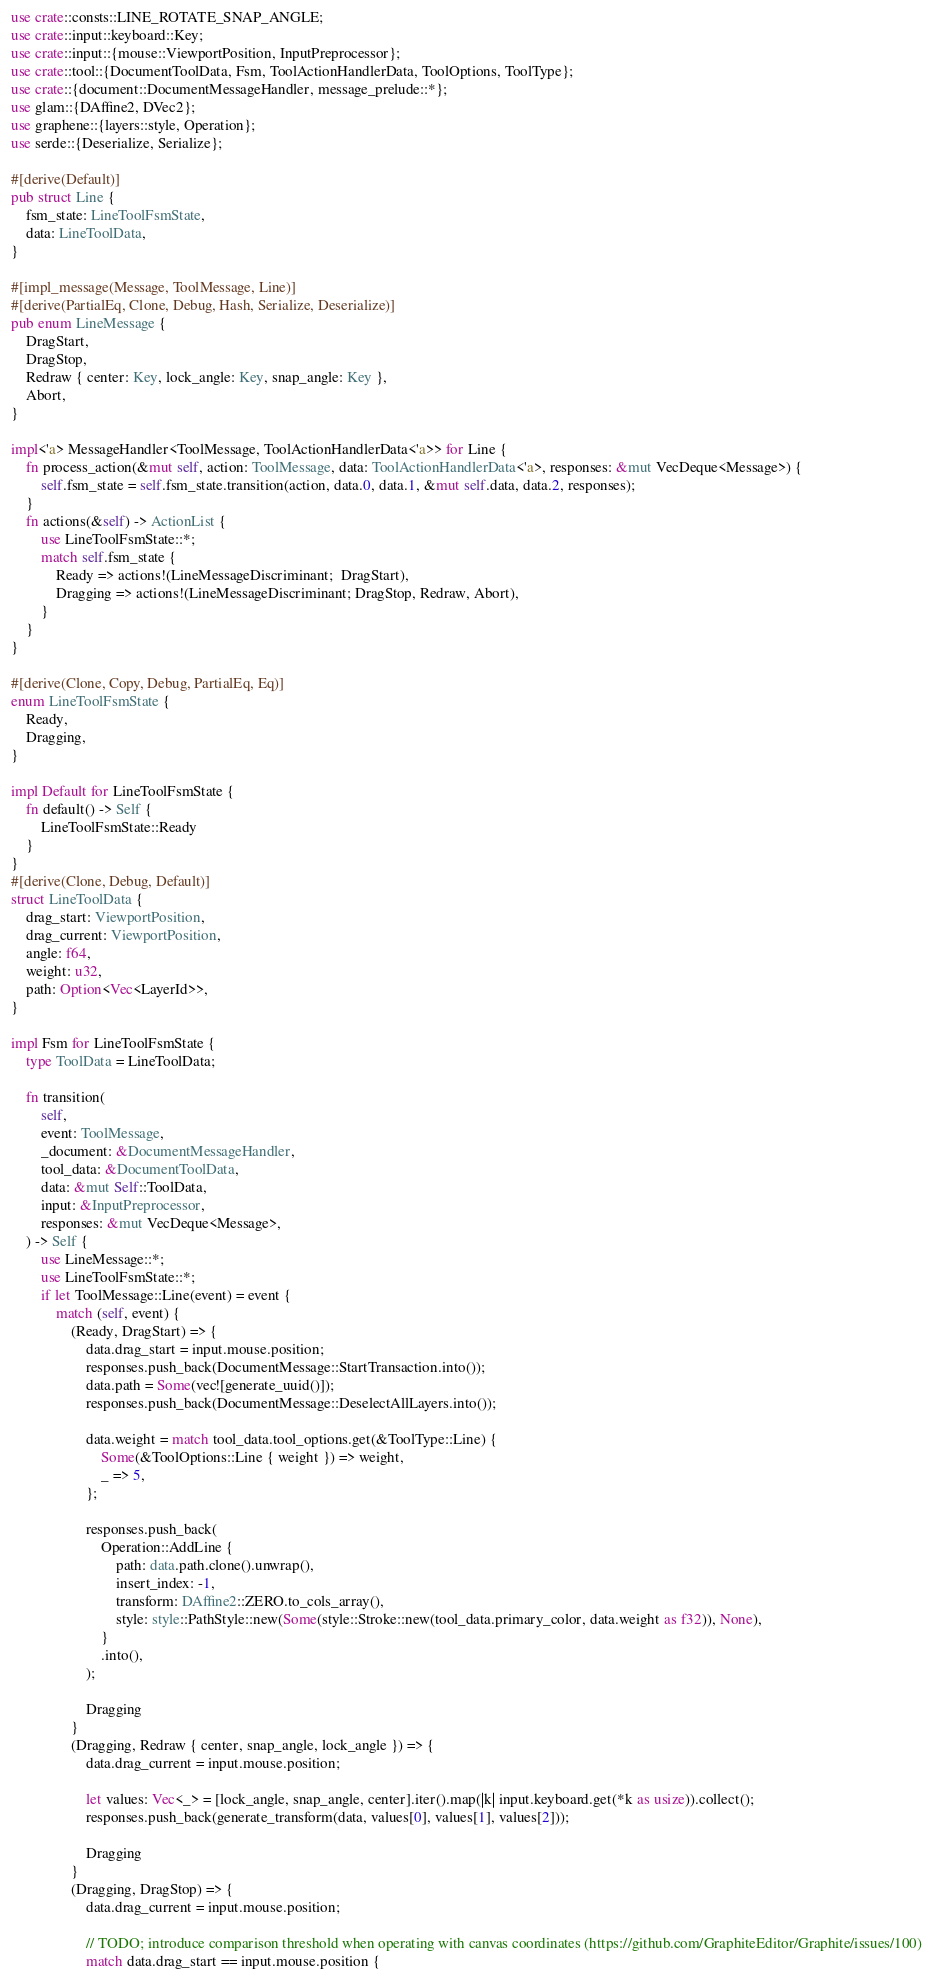Convert code to text. <code><loc_0><loc_0><loc_500><loc_500><_Rust_>use crate::consts::LINE_ROTATE_SNAP_ANGLE;
use crate::input::keyboard::Key;
use crate::input::{mouse::ViewportPosition, InputPreprocessor};
use crate::tool::{DocumentToolData, Fsm, ToolActionHandlerData, ToolOptions, ToolType};
use crate::{document::DocumentMessageHandler, message_prelude::*};
use glam::{DAffine2, DVec2};
use graphene::{layers::style, Operation};
use serde::{Deserialize, Serialize};

#[derive(Default)]
pub struct Line {
	fsm_state: LineToolFsmState,
	data: LineToolData,
}

#[impl_message(Message, ToolMessage, Line)]
#[derive(PartialEq, Clone, Debug, Hash, Serialize, Deserialize)]
pub enum LineMessage {
	DragStart,
	DragStop,
	Redraw { center: Key, lock_angle: Key, snap_angle: Key },
	Abort,
}

impl<'a> MessageHandler<ToolMessage, ToolActionHandlerData<'a>> for Line {
	fn process_action(&mut self, action: ToolMessage, data: ToolActionHandlerData<'a>, responses: &mut VecDeque<Message>) {
		self.fsm_state = self.fsm_state.transition(action, data.0, data.1, &mut self.data, data.2, responses);
	}
	fn actions(&self) -> ActionList {
		use LineToolFsmState::*;
		match self.fsm_state {
			Ready => actions!(LineMessageDiscriminant;  DragStart),
			Dragging => actions!(LineMessageDiscriminant; DragStop, Redraw, Abort),
		}
	}
}

#[derive(Clone, Copy, Debug, PartialEq, Eq)]
enum LineToolFsmState {
	Ready,
	Dragging,
}

impl Default for LineToolFsmState {
	fn default() -> Self {
		LineToolFsmState::Ready
	}
}
#[derive(Clone, Debug, Default)]
struct LineToolData {
	drag_start: ViewportPosition,
	drag_current: ViewportPosition,
	angle: f64,
	weight: u32,
	path: Option<Vec<LayerId>>,
}

impl Fsm for LineToolFsmState {
	type ToolData = LineToolData;

	fn transition(
		self,
		event: ToolMessage,
		_document: &DocumentMessageHandler,
		tool_data: &DocumentToolData,
		data: &mut Self::ToolData,
		input: &InputPreprocessor,
		responses: &mut VecDeque<Message>,
	) -> Self {
		use LineMessage::*;
		use LineToolFsmState::*;
		if let ToolMessage::Line(event) = event {
			match (self, event) {
				(Ready, DragStart) => {
					data.drag_start = input.mouse.position;
					responses.push_back(DocumentMessage::StartTransaction.into());
					data.path = Some(vec![generate_uuid()]);
					responses.push_back(DocumentMessage::DeselectAllLayers.into());

					data.weight = match tool_data.tool_options.get(&ToolType::Line) {
						Some(&ToolOptions::Line { weight }) => weight,
						_ => 5,
					};

					responses.push_back(
						Operation::AddLine {
							path: data.path.clone().unwrap(),
							insert_index: -1,
							transform: DAffine2::ZERO.to_cols_array(),
							style: style::PathStyle::new(Some(style::Stroke::new(tool_data.primary_color, data.weight as f32)), None),
						}
						.into(),
					);

					Dragging
				}
				(Dragging, Redraw { center, snap_angle, lock_angle }) => {
					data.drag_current = input.mouse.position;

					let values: Vec<_> = [lock_angle, snap_angle, center].iter().map(|k| input.keyboard.get(*k as usize)).collect();
					responses.push_back(generate_transform(data, values[0], values[1], values[2]));

					Dragging
				}
				(Dragging, DragStop) => {
					data.drag_current = input.mouse.position;

					// TODO; introduce comparison threshold when operating with canvas coordinates (https://github.com/GraphiteEditor/Graphite/issues/100)
					match data.drag_start == input.mouse.position {</code> 